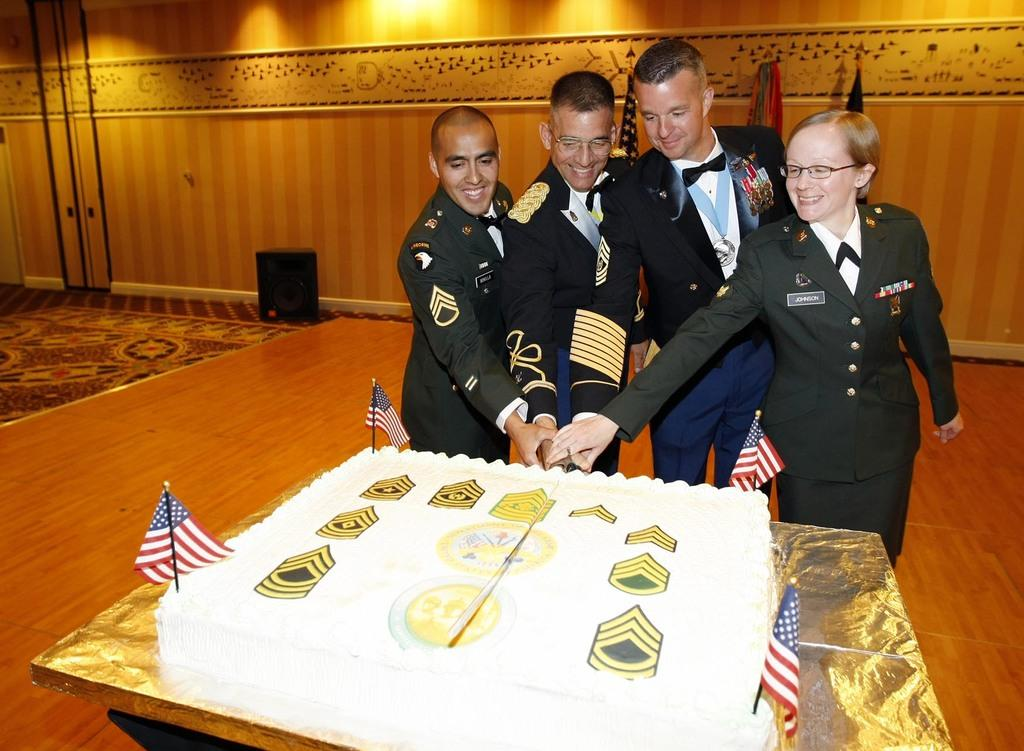What is happening in the image involving the people? The people are cutting a cake in the image. What are the people doing while cutting the cake? The people are standing and smiling while cutting the cake. What object is being used to cut the cake? They are holding a knife to cut the cake. What can be seen in the background of the image? There is a wall in the background of the image. How many rabbits are hopping around the people in the image? There are no rabbits present in the image. What is the value of the cake being cut in the image? The value of the cake cannot be determined from the image. 